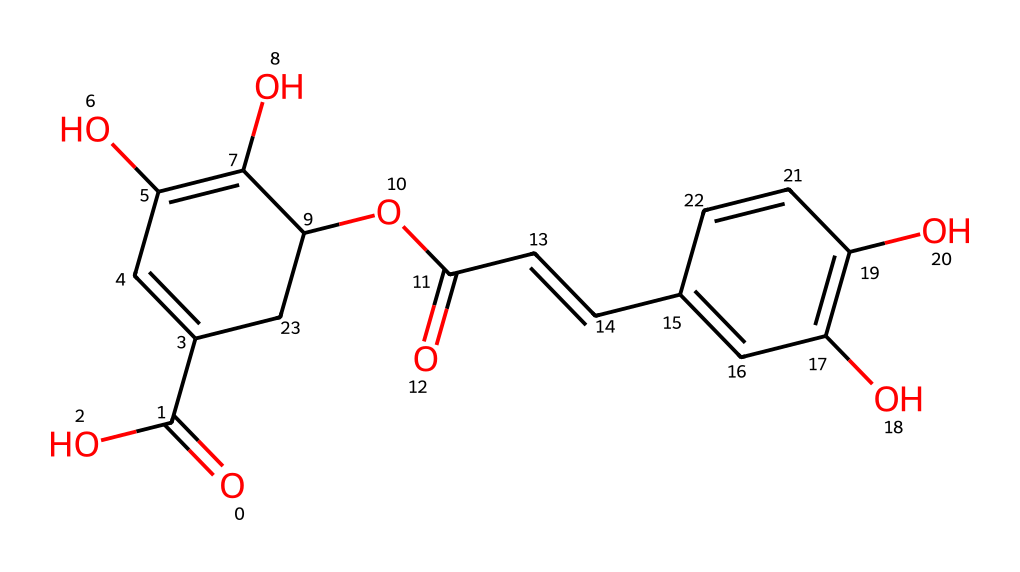What is the overall molecular formula of chlorogenic acid based on the structure? To determine the overall molecular formula, identify the number of carbon (C), hydrogen (H), and oxygen (O) atoms in the structure. After analyzing the structure, it is found to have 18 carbon atoms, 18 hydrogen atoms, and 9 oxygen atoms. Thus, the molecular formula is C18H18O9.
Answer: C18H18O9 How many phenolic groups are present in this structure? A phenolic group is characterized by a hydroxyl group (-OH) attached to an aromatic hydrocarbon. By reviewing the structure, there are two distinct aromatic rings present, and each contains hydroxyl functional groups, confirming that there are two phenolic groups.
Answer: 2 What types of bonds are predominantly present in chlorogenic acid? The predominant types of bonds in chlorogenic acid can be identified by examining the connections between atoms. In this chemical, single bonds (C-C, C-O) and some double bonds (C=C, C=O) are evident. Overall, the structure exhibits both types of bonds, but single bonds are more numerous.
Answer: single and double bonds What characteristic of chlorogenic acid contributes to its antioxidant properties? The antioxidant properties of chlorogenic acid are primarily attributed to the presence of phenolic hydroxyl groups that donate electrons, neutralizing free radicals. Analyzing the structure reveals multiple hydroxyl groups on the phenolic rings, which are key contributors to its antioxidant activity.
Answer: phenolic hydroxyl groups What is the significance of the ester linkage present in this chemical structure? The ester linkage in chlorogenic acid is formed between a carboxylic acid group and an alcohol group. This type of linkage contributes to the overall structure's stability and influences its bioavailability and activity as an antioxidant. The structural review shows that this ester linkage is integral to its chemical properties.
Answer: stability and bioavailability How many chiral centers are present in chlorogenic acid? A chiral center is identified by a carbon atom bonded to four different groups. By examining the structure of chlorogenic acid, there are no carbon atoms that meet this criterion; thus, it is determined that there are zero chiral centers in this molecule.
Answer: 0 